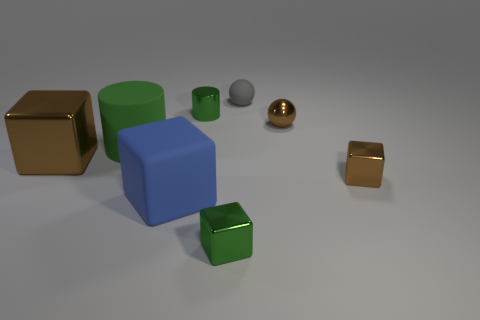Subtract all metallic cubes. How many cubes are left? 1 Add 2 small yellow matte cylinders. How many objects exist? 10 Subtract all cylinders. How many objects are left? 6 Subtract all blue cubes. How many cubes are left? 3 Subtract 0 yellow spheres. How many objects are left? 8 Subtract 1 cylinders. How many cylinders are left? 1 Subtract all brown spheres. Subtract all red blocks. How many spheres are left? 1 Subtract all purple cubes. How many gray cylinders are left? 0 Subtract all shiny blocks. Subtract all large green cylinders. How many objects are left? 4 Add 4 blue matte blocks. How many blue matte blocks are left? 5 